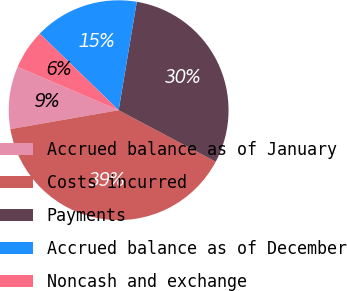<chart> <loc_0><loc_0><loc_500><loc_500><pie_chart><fcel>Accrued balance as of January<fcel>Costs incurred<fcel>Payments<fcel>Accrued balance as of December<fcel>Noncash and exchange<nl><fcel>9.19%<fcel>39.48%<fcel>30.13%<fcel>15.38%<fcel>5.82%<nl></chart> 